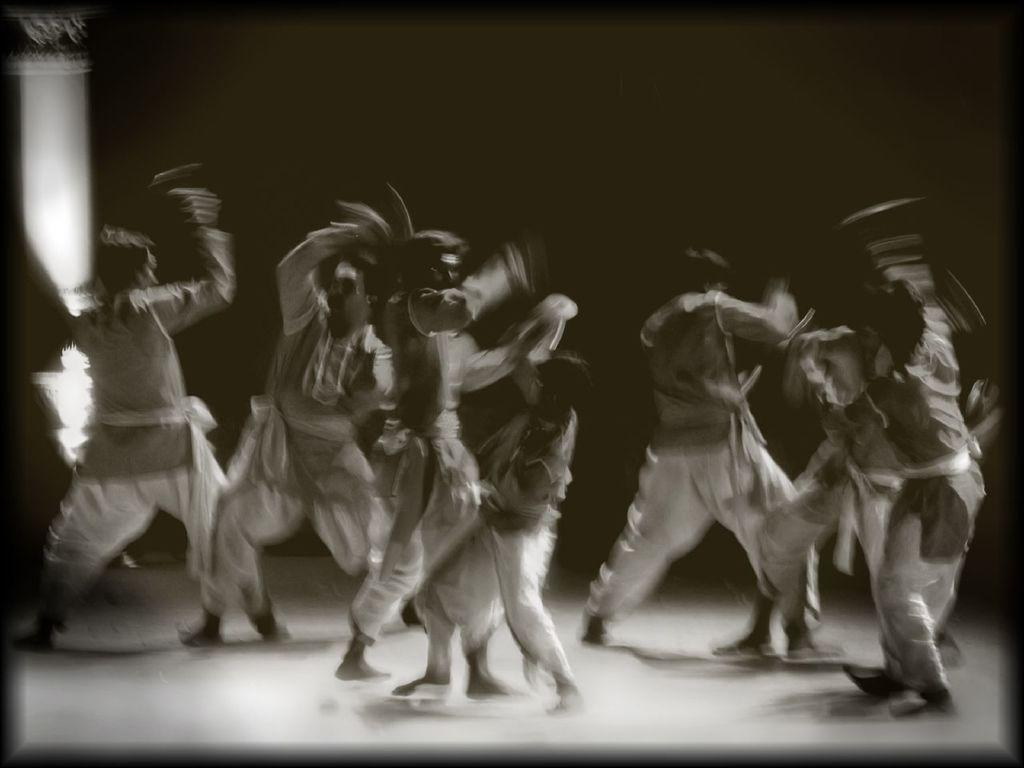How many people are in the image? There are persons in the image. What are the persons in the image doing? The persons appear to be acting in a play. Can you describe the volleyball court in the image? There is no volleyball court present in the image. What is the plot of the play being performed in the image? The facts provided do not give any information about the plot of the play, so it cannot be determined from the image. 